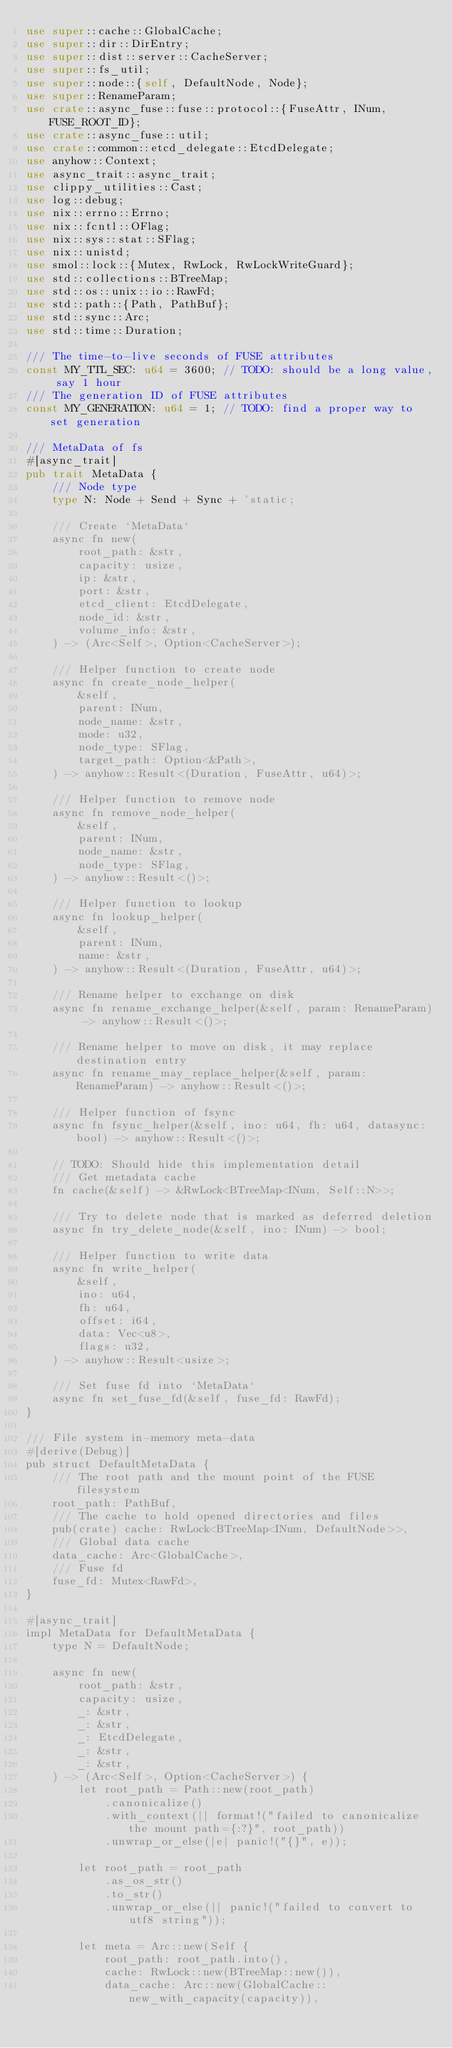<code> <loc_0><loc_0><loc_500><loc_500><_Rust_>use super::cache::GlobalCache;
use super::dir::DirEntry;
use super::dist::server::CacheServer;
use super::fs_util;
use super::node::{self, DefaultNode, Node};
use super::RenameParam;
use crate::async_fuse::fuse::protocol::{FuseAttr, INum, FUSE_ROOT_ID};
use crate::async_fuse::util;
use crate::common::etcd_delegate::EtcdDelegate;
use anyhow::Context;
use async_trait::async_trait;
use clippy_utilities::Cast;
use log::debug;
use nix::errno::Errno;
use nix::fcntl::OFlag;
use nix::sys::stat::SFlag;
use nix::unistd;
use smol::lock::{Mutex, RwLock, RwLockWriteGuard};
use std::collections::BTreeMap;
use std::os::unix::io::RawFd;
use std::path::{Path, PathBuf};
use std::sync::Arc;
use std::time::Duration;

/// The time-to-live seconds of FUSE attributes
const MY_TTL_SEC: u64 = 3600; // TODO: should be a long value, say 1 hour
/// The generation ID of FUSE attributes
const MY_GENERATION: u64 = 1; // TODO: find a proper way to set generation

/// MetaData of fs
#[async_trait]
pub trait MetaData {
    /// Node type
    type N: Node + Send + Sync + 'static;

    /// Create `MetaData`
    async fn new(
        root_path: &str,
        capacity: usize,
        ip: &str,
        port: &str,
        etcd_client: EtcdDelegate,
        node_id: &str,
        volume_info: &str,
    ) -> (Arc<Self>, Option<CacheServer>);

    /// Helper function to create node
    async fn create_node_helper(
        &self,
        parent: INum,
        node_name: &str,
        mode: u32,
        node_type: SFlag,
        target_path: Option<&Path>,
    ) -> anyhow::Result<(Duration, FuseAttr, u64)>;

    /// Helper function to remove node
    async fn remove_node_helper(
        &self,
        parent: INum,
        node_name: &str,
        node_type: SFlag,
    ) -> anyhow::Result<()>;

    /// Helper function to lookup
    async fn lookup_helper(
        &self,
        parent: INum,
        name: &str,
    ) -> anyhow::Result<(Duration, FuseAttr, u64)>;

    /// Rename helper to exchange on disk
    async fn rename_exchange_helper(&self, param: RenameParam) -> anyhow::Result<()>;

    /// Rename helper to move on disk, it may replace destination entry
    async fn rename_may_replace_helper(&self, param: RenameParam) -> anyhow::Result<()>;

    /// Helper function of fsync
    async fn fsync_helper(&self, ino: u64, fh: u64, datasync: bool) -> anyhow::Result<()>;

    // TODO: Should hide this implementation detail
    /// Get metadata cache
    fn cache(&self) -> &RwLock<BTreeMap<INum, Self::N>>;

    /// Try to delete node that is marked as deferred deletion
    async fn try_delete_node(&self, ino: INum) -> bool;

    /// Helper function to write data
    async fn write_helper(
        &self,
        ino: u64,
        fh: u64,
        offset: i64,
        data: Vec<u8>,
        flags: u32,
    ) -> anyhow::Result<usize>;

    /// Set fuse fd into `MetaData`
    async fn set_fuse_fd(&self, fuse_fd: RawFd);
}

/// File system in-memory meta-data
#[derive(Debug)]
pub struct DefaultMetaData {
    /// The root path and the mount point of the FUSE filesystem
    root_path: PathBuf,
    /// The cache to hold opened directories and files
    pub(crate) cache: RwLock<BTreeMap<INum, DefaultNode>>,
    /// Global data cache
    data_cache: Arc<GlobalCache>,
    /// Fuse fd
    fuse_fd: Mutex<RawFd>,
}

#[async_trait]
impl MetaData for DefaultMetaData {
    type N = DefaultNode;

    async fn new(
        root_path: &str,
        capacity: usize,
        _: &str,
        _: &str,
        _: EtcdDelegate,
        _: &str,
        _: &str,
    ) -> (Arc<Self>, Option<CacheServer>) {
        let root_path = Path::new(root_path)
            .canonicalize()
            .with_context(|| format!("failed to canonicalize the mount path={:?}", root_path))
            .unwrap_or_else(|e| panic!("{}", e));

        let root_path = root_path
            .as_os_str()
            .to_str()
            .unwrap_or_else(|| panic!("failed to convert to utf8 string"));

        let meta = Arc::new(Self {
            root_path: root_path.into(),
            cache: RwLock::new(BTreeMap::new()),
            data_cache: Arc::new(GlobalCache::new_with_capacity(capacity)),</code> 